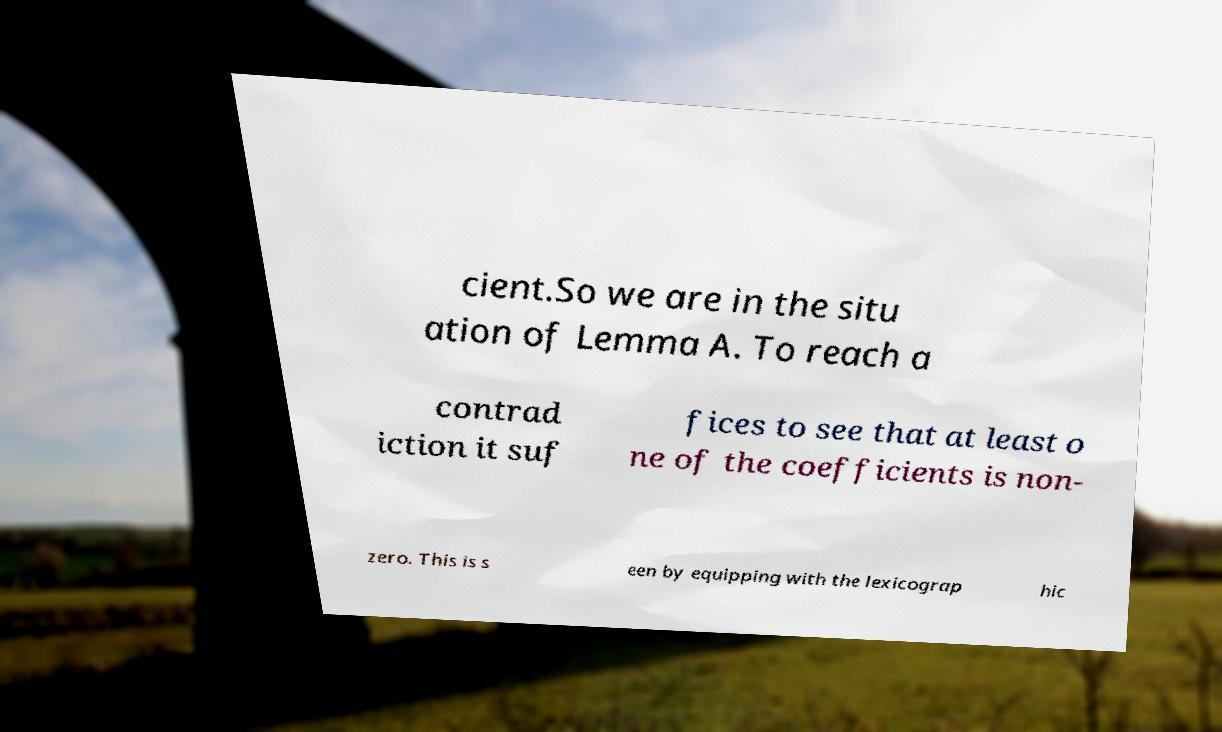There's text embedded in this image that I need extracted. Can you transcribe it verbatim? cient.So we are in the situ ation of Lemma A. To reach a contrad iction it suf fices to see that at least o ne of the coefficients is non- zero. This is s een by equipping with the lexicograp hic 